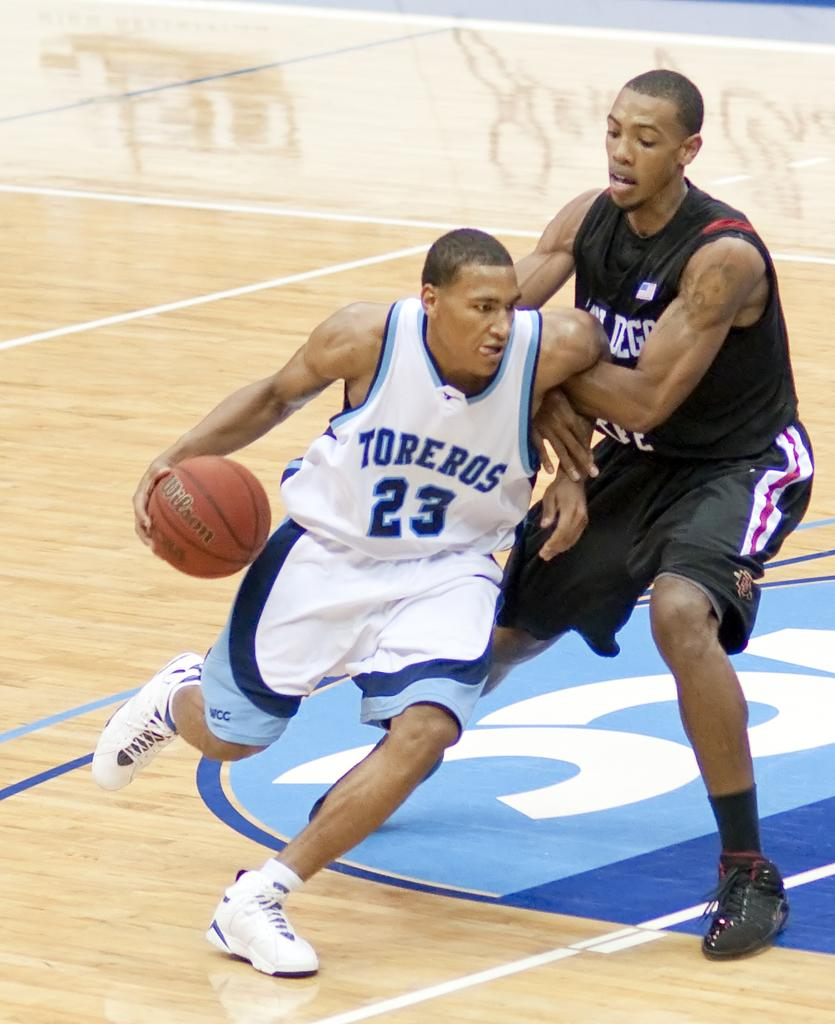<image>
Give a short and clear explanation of the subsequent image. basketball players with one of them wearing a jersey that says 'toreros' on it 